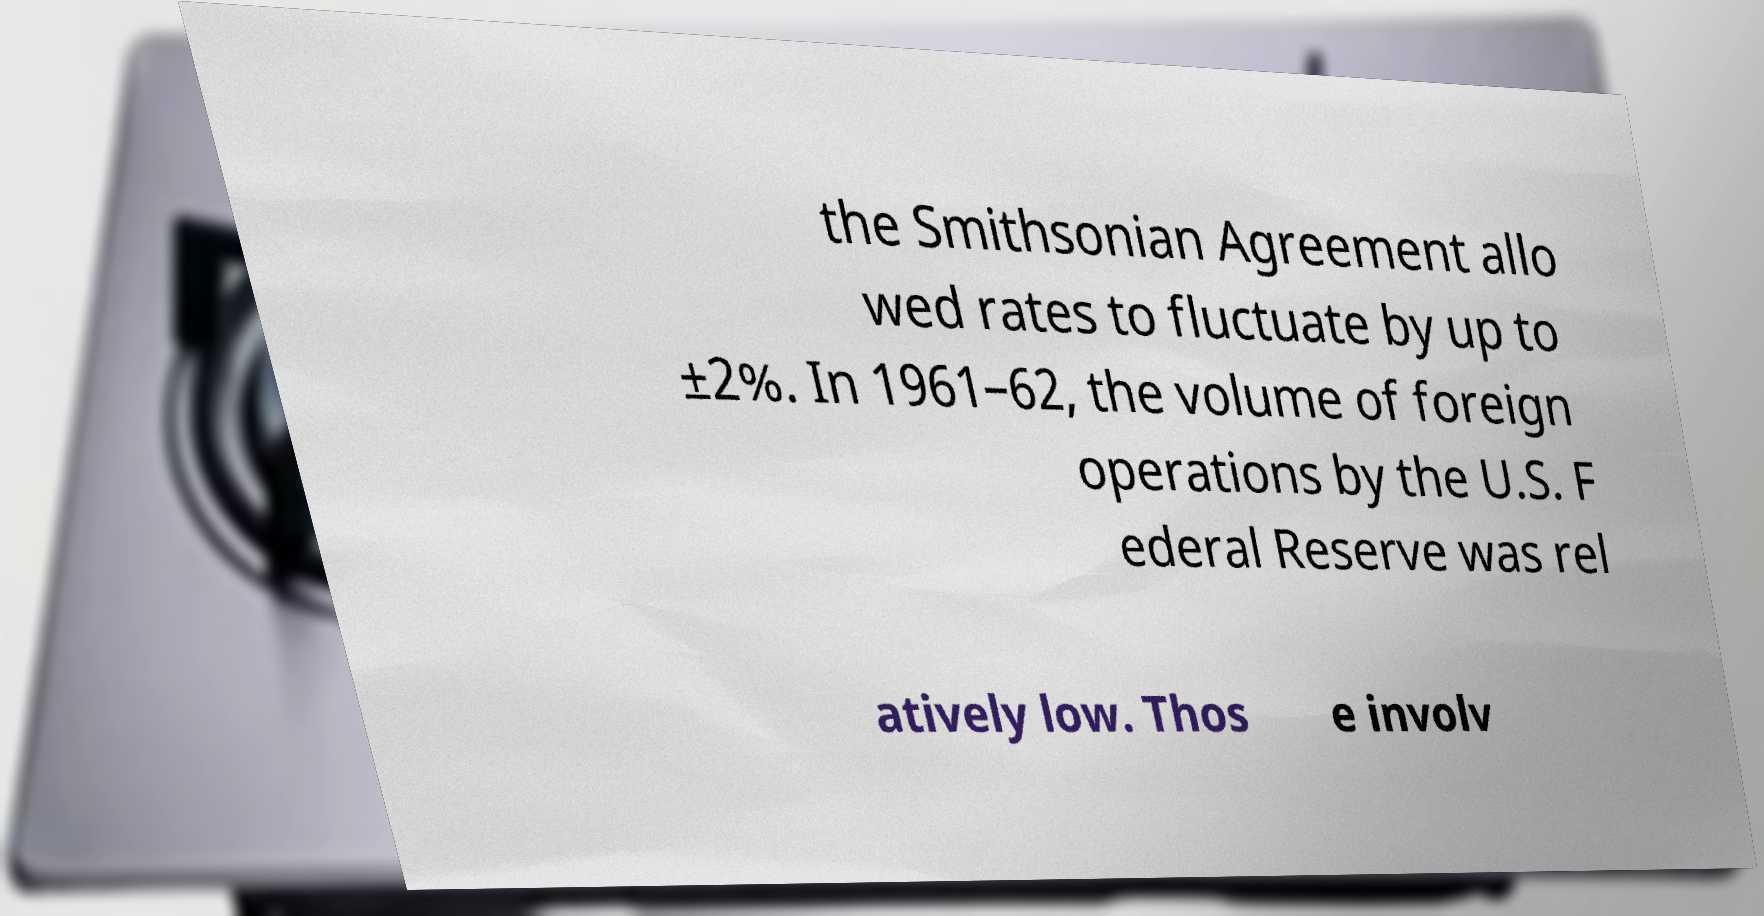Can you read and provide the text displayed in the image?This photo seems to have some interesting text. Can you extract and type it out for me? the Smithsonian Agreement allo wed rates to fluctuate by up to ±2%. In 1961–62, the volume of foreign operations by the U.S. F ederal Reserve was rel atively low. Thos e involv 